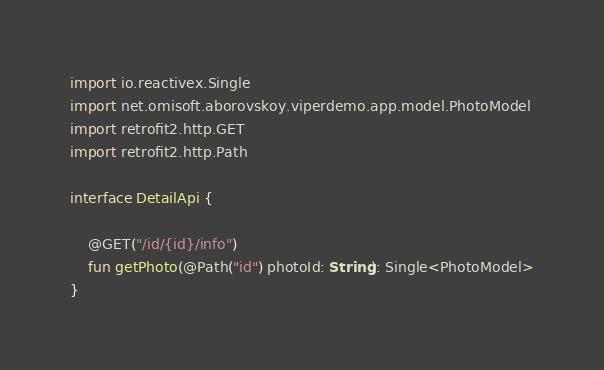Convert code to text. <code><loc_0><loc_0><loc_500><loc_500><_Kotlin_>import io.reactivex.Single
import net.omisoft.aborovskoy.viperdemo.app.model.PhotoModel
import retrofit2.http.GET
import retrofit2.http.Path

interface DetailApi {

    @GET("/id/{id}/info")
    fun getPhoto(@Path("id") photoId: String): Single<PhotoModel>
}</code> 